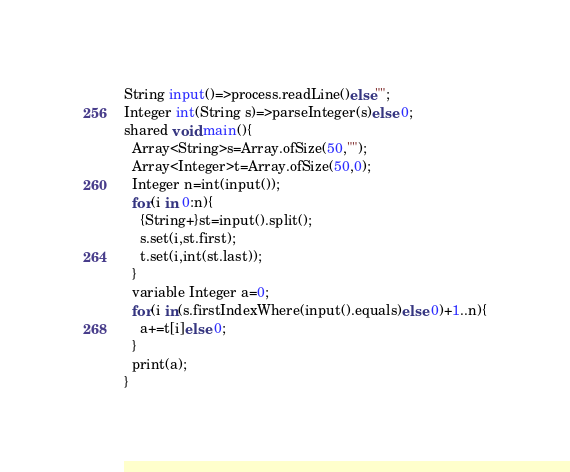Convert code to text. <code><loc_0><loc_0><loc_500><loc_500><_Ceylon_>String input()=>process.readLine()else""; 
Integer int(String s)=>parseInteger(s)else 0;
shared void main(){
  Array<String>s=Array.ofSize(50,"");
  Array<Integer>t=Array.ofSize(50,0);
  Integer n=int(input());
  for(i in 0:n){
    {String+}st=input().split();
    s.set(i,st.first);
    t.set(i,int(st.last));
  }
  variable Integer a=0;
  for(i in(s.firstIndexWhere(input().equals)else 0)+1..n){
    a+=t[i]else 0;
  }
  print(a);
}
</code> 